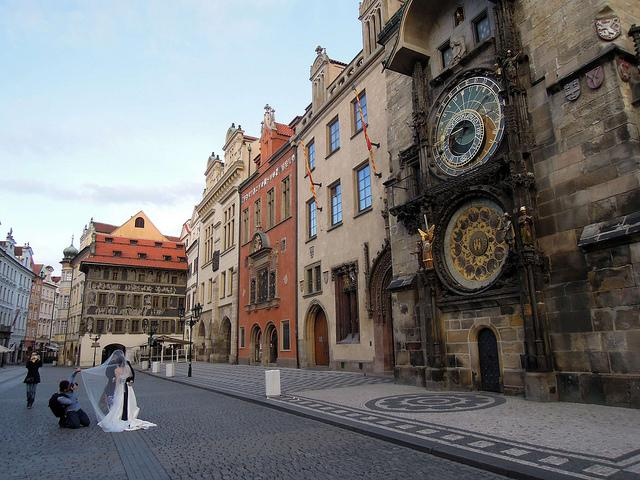What occasion is now photographed underneath the clock faces? wedding 